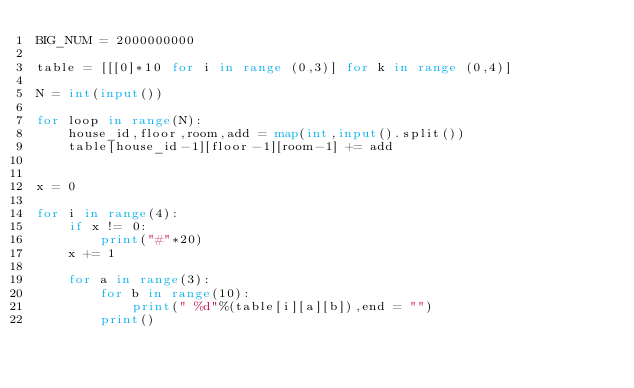<code> <loc_0><loc_0><loc_500><loc_500><_Python_>BIG_NUM = 2000000000

table = [[[0]*10 for i in range (0,3)] for k in range (0,4)]

N = int(input())

for loop in range(N):
    house_id,floor,room,add = map(int,input().split())
    table[house_id-1][floor-1][room-1] += add


x = 0

for i in range(4):
    if x != 0:
        print("#"*20)
    x += 1

    for a in range(3):
        for b in range(10):
            print(" %d"%(table[i][a][b]),end = "")
        print()
</code> 